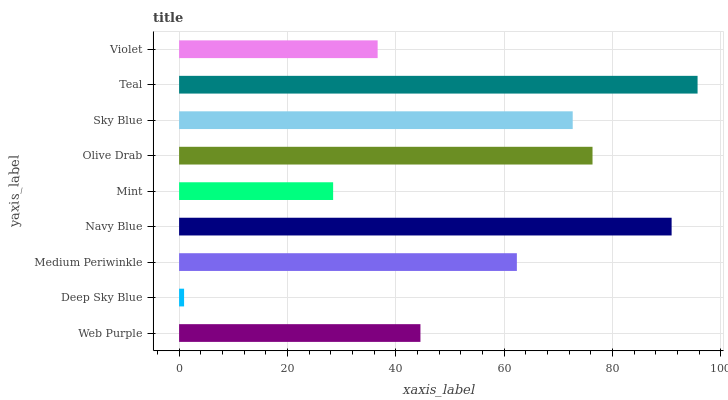Is Deep Sky Blue the minimum?
Answer yes or no. Yes. Is Teal the maximum?
Answer yes or no. Yes. Is Medium Periwinkle the minimum?
Answer yes or no. No. Is Medium Periwinkle the maximum?
Answer yes or no. No. Is Medium Periwinkle greater than Deep Sky Blue?
Answer yes or no. Yes. Is Deep Sky Blue less than Medium Periwinkle?
Answer yes or no. Yes. Is Deep Sky Blue greater than Medium Periwinkle?
Answer yes or no. No. Is Medium Periwinkle less than Deep Sky Blue?
Answer yes or no. No. Is Medium Periwinkle the high median?
Answer yes or no. Yes. Is Medium Periwinkle the low median?
Answer yes or no. Yes. Is Navy Blue the high median?
Answer yes or no. No. Is Mint the low median?
Answer yes or no. No. 